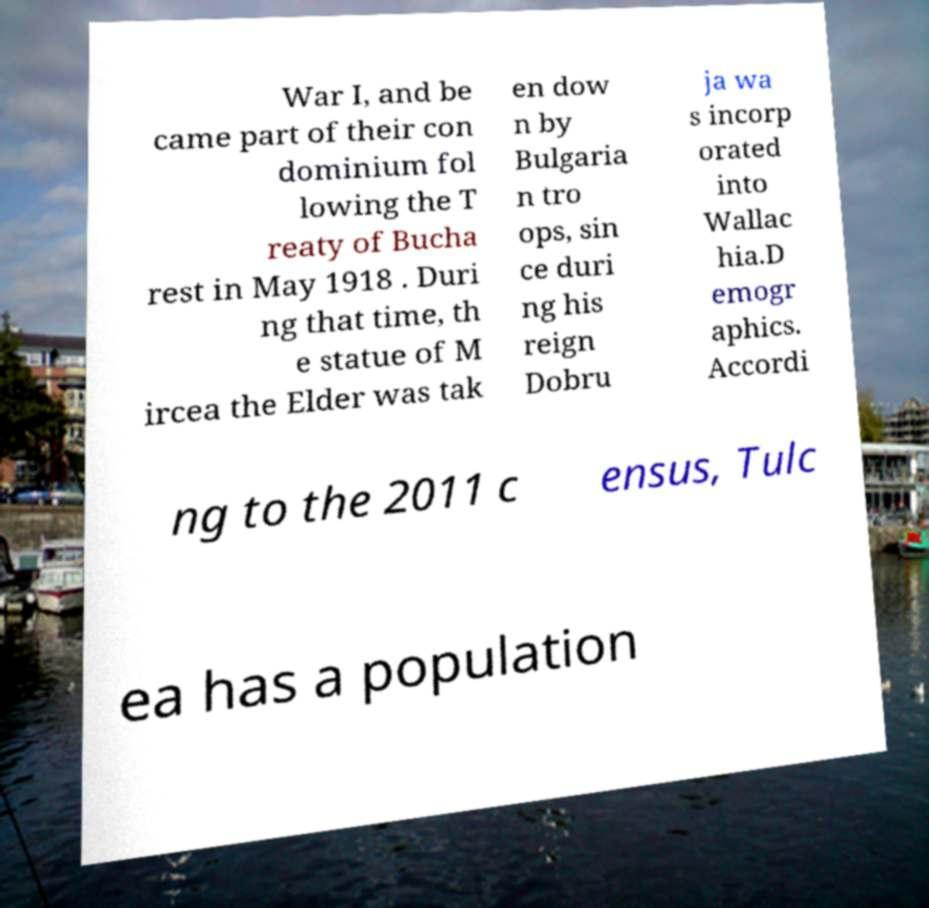For documentation purposes, I need the text within this image transcribed. Could you provide that? War I, and be came part of their con dominium fol lowing the T reaty of Bucha rest in May 1918 . Duri ng that time, th e statue of M ircea the Elder was tak en dow n by Bulgaria n tro ops, sin ce duri ng his reign Dobru ja wa s incorp orated into Wallac hia.D emogr aphics. Accordi ng to the 2011 c ensus, Tulc ea has a population 